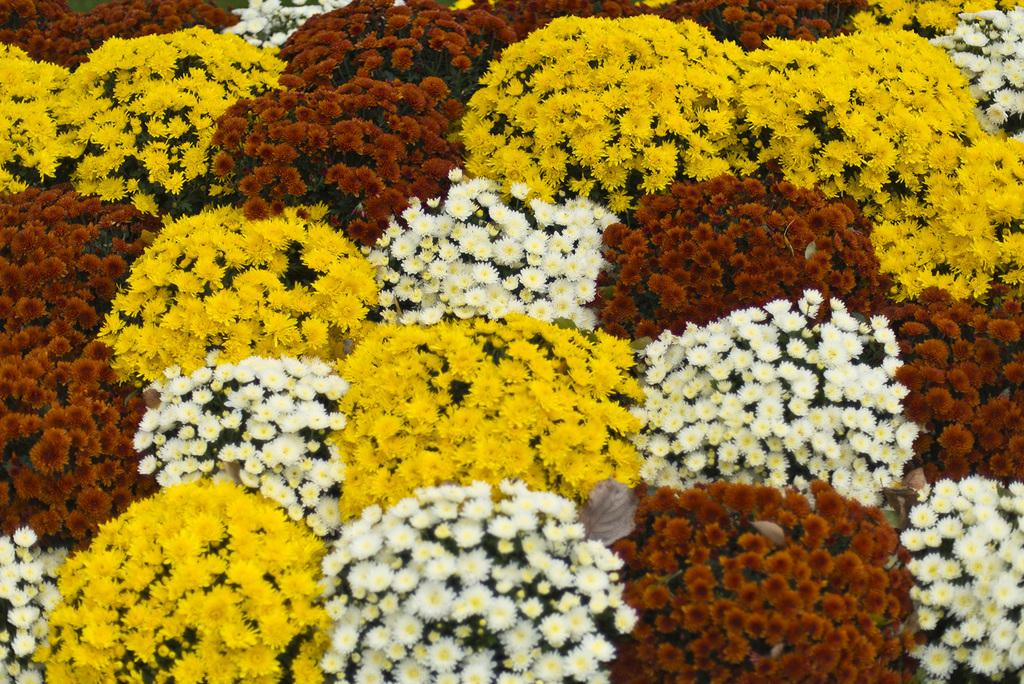What type of flowers are present in the image? There are many sunflowers in the image. What colors can be seen in the sunflowers? The sunflowers are of yellow, white, and red colors. How are the sunflowers distributed in the image? The sunflowers are spread all over the place. Can you see any islands in the image? There are no islands present in the image; it features sunflowers. What type of brush is used to paint the sunflowers in the image? The image is not a painting, so there is no brush used to create it. 